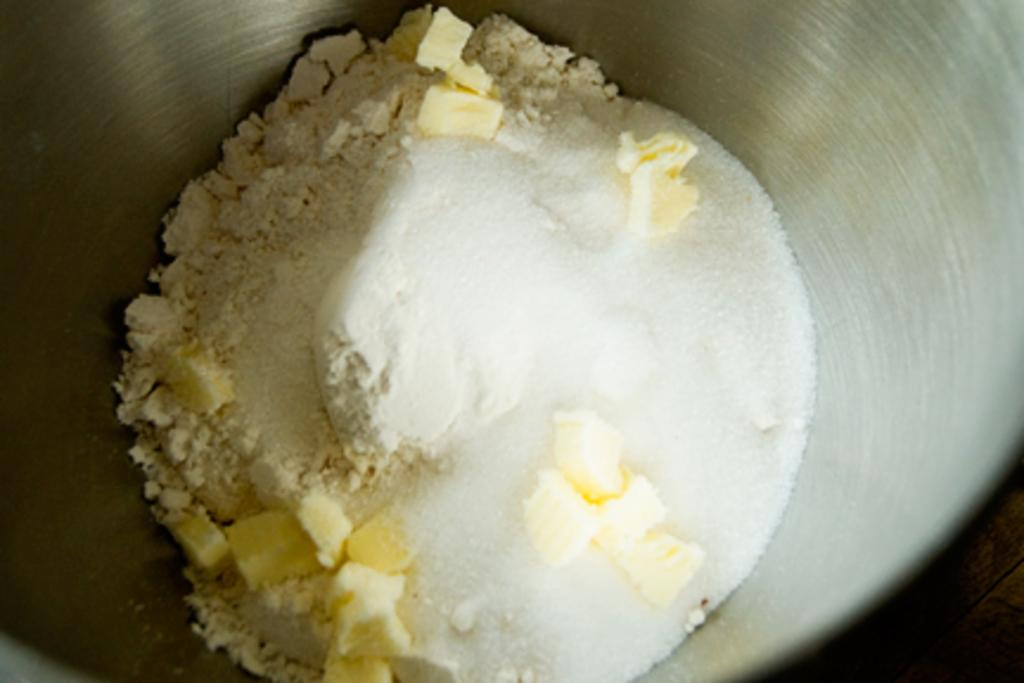What type of ingredient can be seen in the image? There is flour, salt, and cheese in the image. How are the ingredients in the image related to each other? The flour, salt, and cheese are mixed together. What type of class is being held in the image? There is no class present in the image; it only shows flour, salt, and cheese being mixed together. 